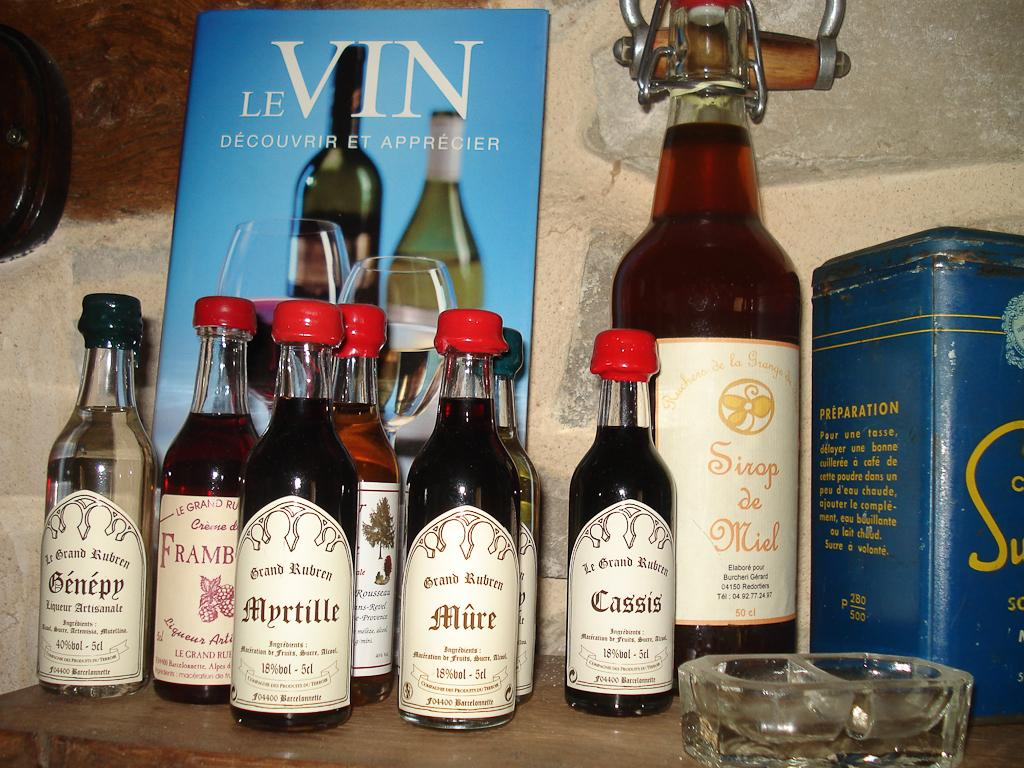<image>
Give a short and clear explanation of the subsequent image. Small bottles contain Cassis, Myrtille, Genepy, Mure and more. 